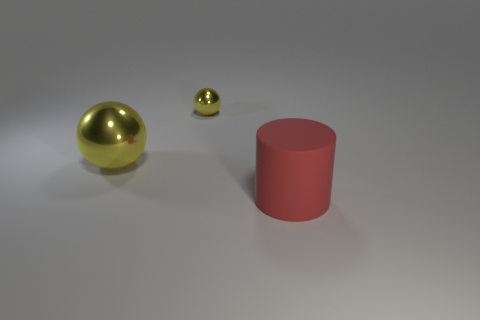How many metal objects are behind the big yellow ball and to the left of the tiny object? 0 